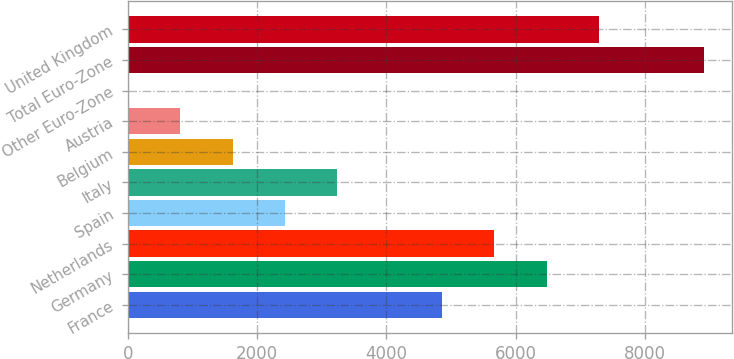<chart> <loc_0><loc_0><loc_500><loc_500><bar_chart><fcel>France<fcel>Germany<fcel>Netherlands<fcel>Spain<fcel>Italy<fcel>Belgium<fcel>Austria<fcel>Other Euro-Zone<fcel>Total Euro-Zone<fcel>United Kingdom<nl><fcel>4860.4<fcel>6480.2<fcel>5670.3<fcel>2430.7<fcel>3240.6<fcel>1620.8<fcel>810.9<fcel>1<fcel>8909.9<fcel>7290.1<nl></chart> 